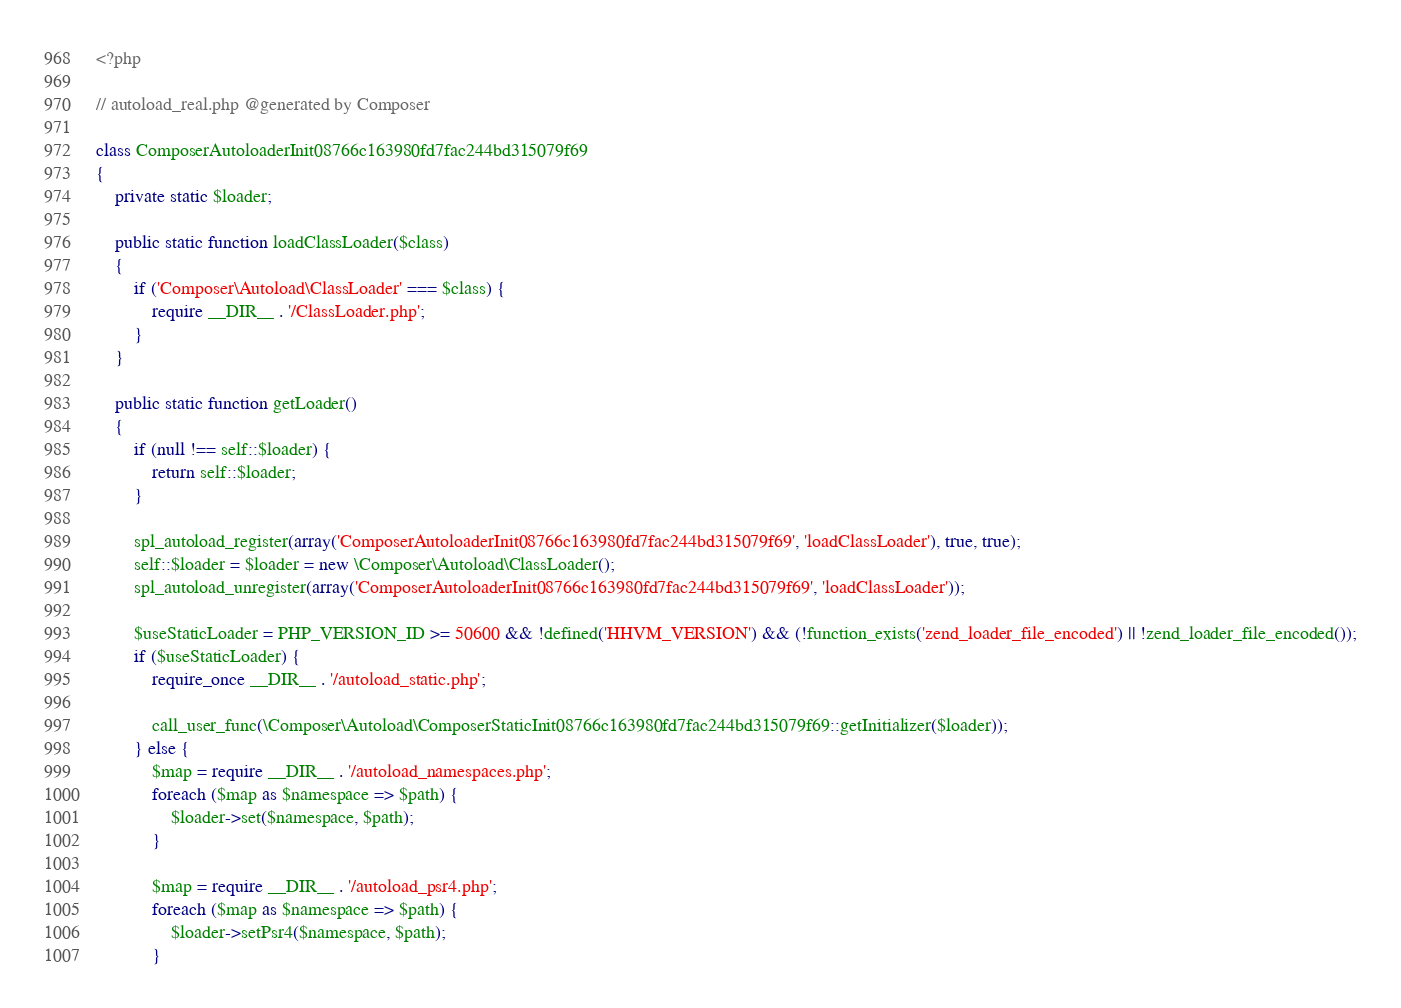<code> <loc_0><loc_0><loc_500><loc_500><_PHP_><?php

// autoload_real.php @generated by Composer

class ComposerAutoloaderInit08766c163980fd7fac244bd315079f69
{
    private static $loader;

    public static function loadClassLoader($class)
    {
        if ('Composer\Autoload\ClassLoader' === $class) {
            require __DIR__ . '/ClassLoader.php';
        }
    }

    public static function getLoader()
    {
        if (null !== self::$loader) {
            return self::$loader;
        }

        spl_autoload_register(array('ComposerAutoloaderInit08766c163980fd7fac244bd315079f69', 'loadClassLoader'), true, true);
        self::$loader = $loader = new \Composer\Autoload\ClassLoader();
        spl_autoload_unregister(array('ComposerAutoloaderInit08766c163980fd7fac244bd315079f69', 'loadClassLoader'));

        $useStaticLoader = PHP_VERSION_ID >= 50600 && !defined('HHVM_VERSION') && (!function_exists('zend_loader_file_encoded') || !zend_loader_file_encoded());
        if ($useStaticLoader) {
            require_once __DIR__ . '/autoload_static.php';

            call_user_func(\Composer\Autoload\ComposerStaticInit08766c163980fd7fac244bd315079f69::getInitializer($loader));
        } else {
            $map = require __DIR__ . '/autoload_namespaces.php';
            foreach ($map as $namespace => $path) {
                $loader->set($namespace, $path);
            }

            $map = require __DIR__ . '/autoload_psr4.php';
            foreach ($map as $namespace => $path) {
                $loader->setPsr4($namespace, $path);
            }
</code> 